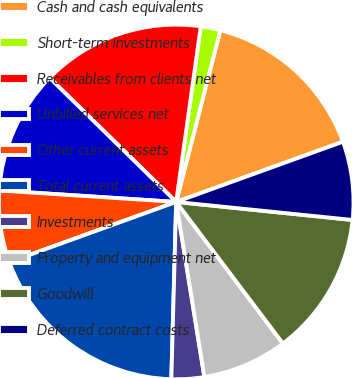Convert chart. <chart><loc_0><loc_0><loc_500><loc_500><pie_chart><fcel>Cash and cash equivalents<fcel>Short-term investments<fcel>Receivables from clients net<fcel>Unbilled services net<fcel>Other current assets<fcel>Total current assets<fcel>Investments<fcel>Property and equipment net<fcel>Goodwill<fcel>Deferred contract costs<nl><fcel>15.48%<fcel>1.79%<fcel>14.88%<fcel>11.31%<fcel>6.55%<fcel>19.05%<fcel>2.98%<fcel>7.74%<fcel>13.1%<fcel>7.14%<nl></chart> 